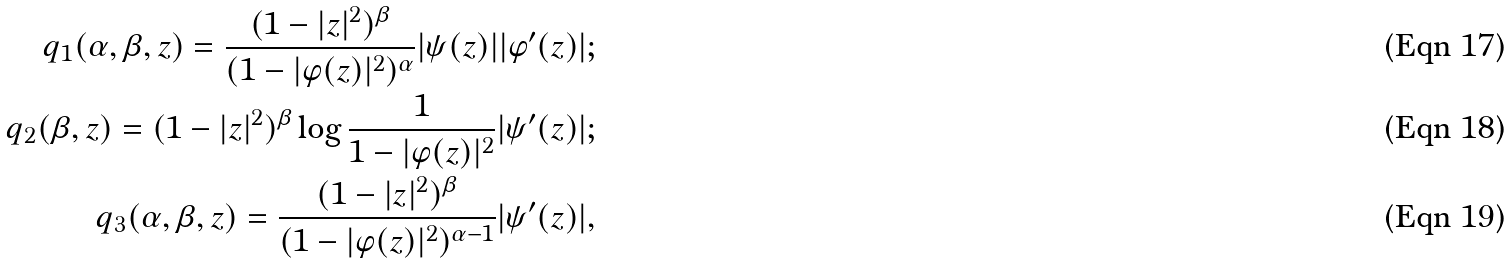Convert formula to latex. <formula><loc_0><loc_0><loc_500><loc_500>q _ { 1 } ( \alpha , \beta , z ) = \frac { ( 1 - | z | ^ { 2 } ) ^ { \beta } } { ( 1 - | \varphi ( z ) | ^ { 2 } ) ^ { \alpha } } | \psi ( z ) | | \varphi ^ { \prime } ( z ) | ; \\ q _ { 2 } ( \beta , z ) = ( 1 - | z | ^ { 2 } ) ^ { \beta } \log \frac { 1 } { 1 - | \varphi ( z ) | ^ { 2 } } | \psi ^ { \prime } ( z ) | ; \\ q _ { 3 } ( \alpha , \beta , z ) = \frac { ( 1 - | z | ^ { 2 } ) ^ { \beta } } { ( 1 - | \varphi ( z ) | ^ { 2 } ) ^ { \alpha - 1 } } | \psi ^ { \prime } ( z ) | ,</formula> 